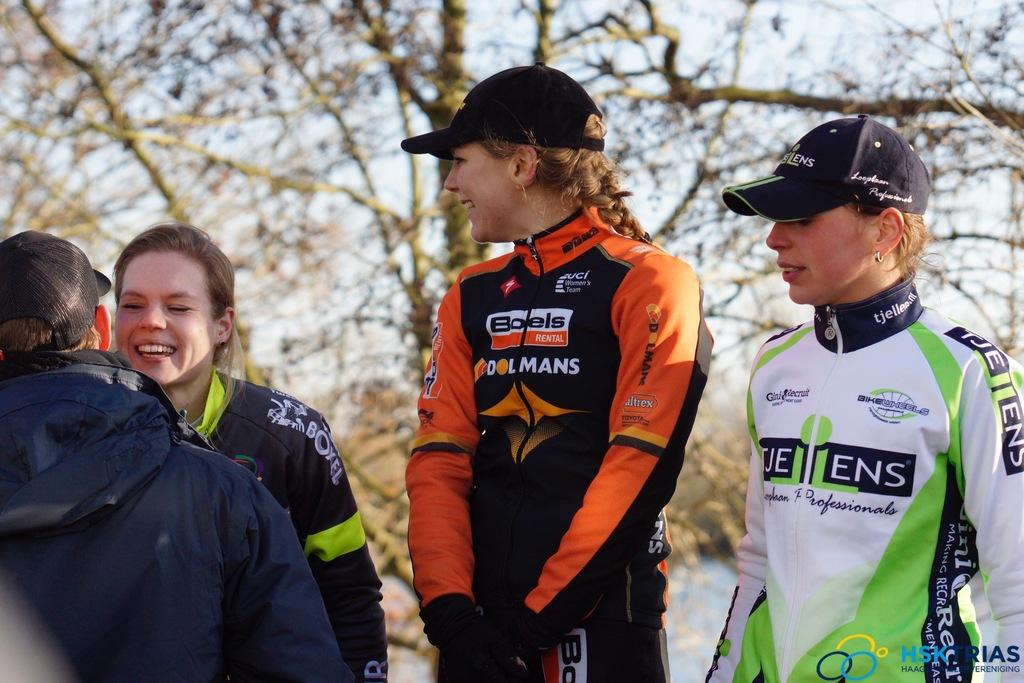<image>
Present a compact description of the photo's key features. three people in front of trees with a girl in the middle wearing a jump suit sponsored by boels rental 